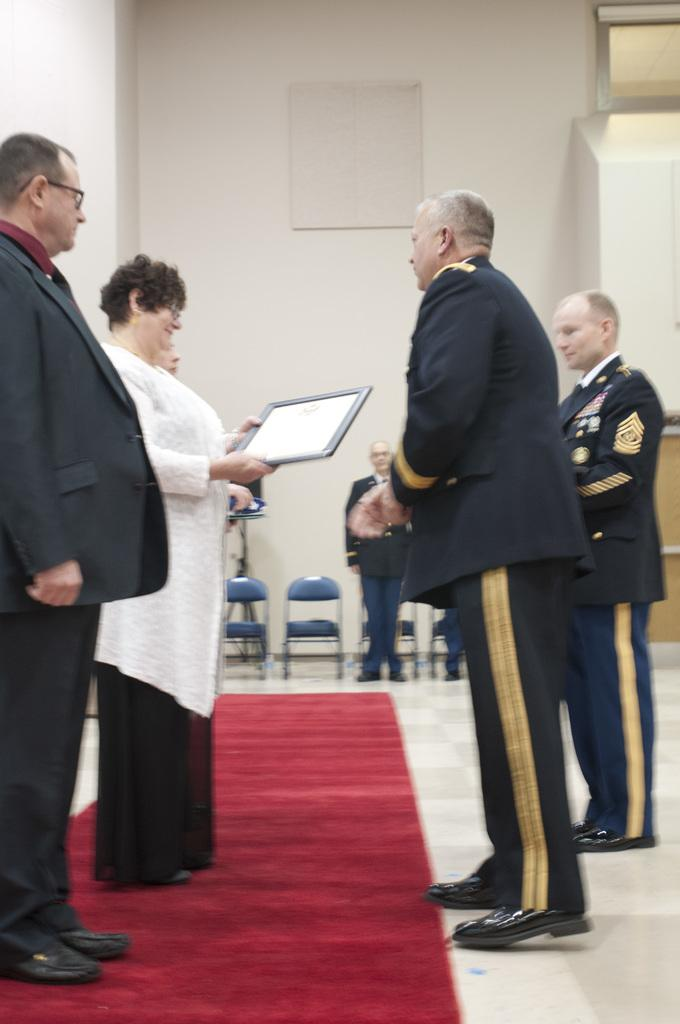What are the people in the image doing? The people in the image are standing on the floor. What is the woman holding in the image? The woman is holding a frame in the image. What can be seen in the background of the image? There are chairs and a wall in the background of the image. How many girls are pushing the beef in the image? There are no girls or beef present in the image. 